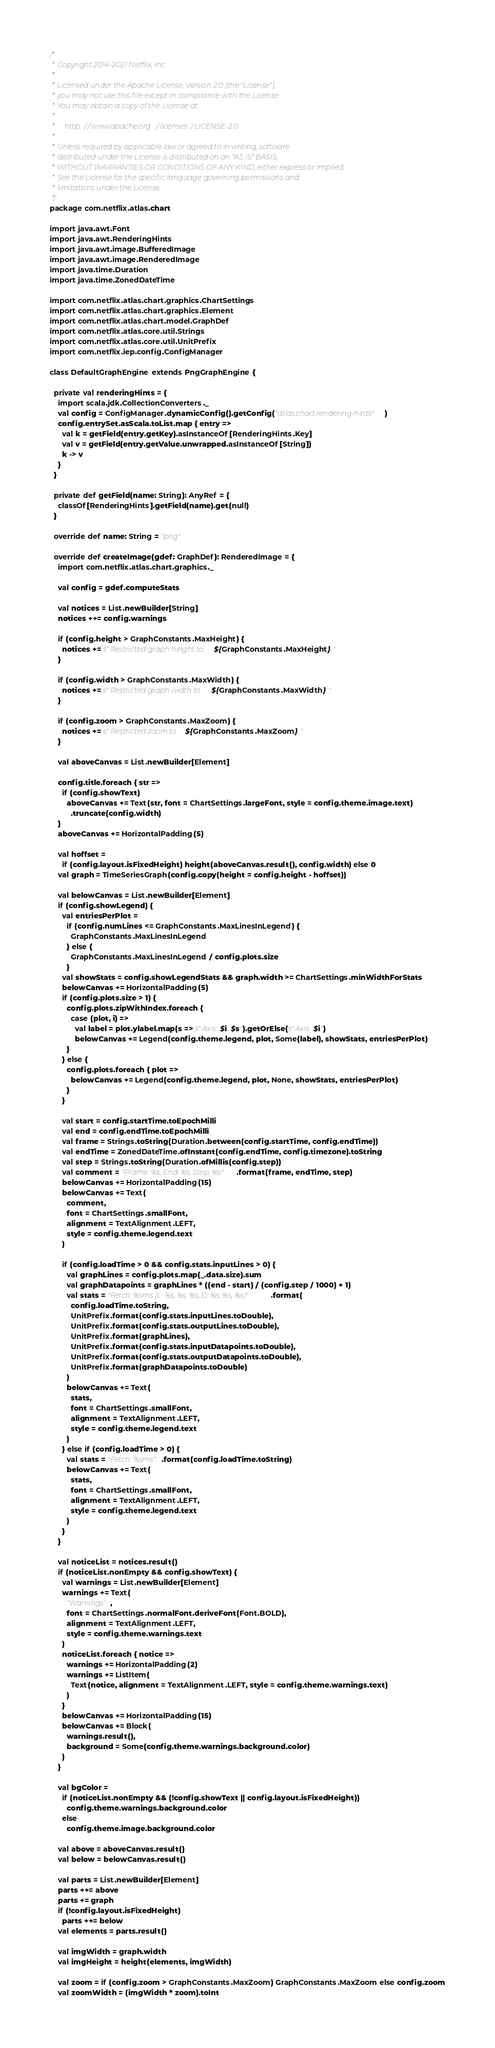Convert code to text. <code><loc_0><loc_0><loc_500><loc_500><_Scala_>/*
 * Copyright 2014-2021 Netflix, Inc.
 *
 * Licensed under the Apache License, Version 2.0 (the "License");
 * you may not use this file except in compliance with the License.
 * You may obtain a copy of the License at
 *
 *     http://www.apache.org/licenses/LICENSE-2.0
 *
 * Unless required by applicable law or agreed to in writing, software
 * distributed under the License is distributed on an "AS IS" BASIS,
 * WITHOUT WARRANTIES OR CONDITIONS OF ANY KIND, either express or implied.
 * See the License for the specific language governing permissions and
 * limitations under the License.
 */
package com.netflix.atlas.chart

import java.awt.Font
import java.awt.RenderingHints
import java.awt.image.BufferedImage
import java.awt.image.RenderedImage
import java.time.Duration
import java.time.ZonedDateTime

import com.netflix.atlas.chart.graphics.ChartSettings
import com.netflix.atlas.chart.graphics.Element
import com.netflix.atlas.chart.model.GraphDef
import com.netflix.atlas.core.util.Strings
import com.netflix.atlas.core.util.UnitPrefix
import com.netflix.iep.config.ConfigManager

class DefaultGraphEngine extends PngGraphEngine {

  private val renderingHints = {
    import scala.jdk.CollectionConverters._
    val config = ConfigManager.dynamicConfig().getConfig("atlas.chart.rendering-hints")
    config.entrySet.asScala.toList.map { entry =>
      val k = getField(entry.getKey).asInstanceOf[RenderingHints.Key]
      val v = getField(entry.getValue.unwrapped.asInstanceOf[String])
      k -> v
    }
  }

  private def getField(name: String): AnyRef = {
    classOf[RenderingHints].getField(name).get(null)
  }

  override def name: String = "png"

  override def createImage(gdef: GraphDef): RenderedImage = {
    import com.netflix.atlas.chart.graphics._

    val config = gdef.computeStats

    val notices = List.newBuilder[String]
    notices ++= config.warnings

    if (config.height > GraphConstants.MaxHeight) {
      notices += s"Restricted graph height to ${GraphConstants.MaxHeight}."
    }

    if (config.width > GraphConstants.MaxWidth) {
      notices += s"Restricted graph width to ${GraphConstants.MaxWidth}."
    }

    if (config.zoom > GraphConstants.MaxZoom) {
      notices += s"Restricted zoom to ${GraphConstants.MaxZoom}."
    }

    val aboveCanvas = List.newBuilder[Element]

    config.title.foreach { str =>
      if (config.showText)
        aboveCanvas += Text(str, font = ChartSettings.largeFont, style = config.theme.image.text)
          .truncate(config.width)
    }
    aboveCanvas += HorizontalPadding(5)

    val hoffset =
      if (config.layout.isFixedHeight) height(aboveCanvas.result(), config.width) else 0
    val graph = TimeSeriesGraph(config.copy(height = config.height - hoffset))

    val belowCanvas = List.newBuilder[Element]
    if (config.showLegend) {
      val entriesPerPlot =
        if (config.numLines <= GraphConstants.MaxLinesInLegend) {
          GraphConstants.MaxLinesInLegend
        } else {
          GraphConstants.MaxLinesInLegend / config.plots.size
        }
      val showStats = config.showLegendStats && graph.width >= ChartSettings.minWidthForStats
      belowCanvas += HorizontalPadding(5)
      if (config.plots.size > 1) {
        config.plots.zipWithIndex.foreach {
          case (plot, i) =>
            val label = plot.ylabel.map(s => s"Axis $i: $s").getOrElse(s"Axis $i")
            belowCanvas += Legend(config.theme.legend, plot, Some(label), showStats, entriesPerPlot)
        }
      } else {
        config.plots.foreach { plot =>
          belowCanvas += Legend(config.theme.legend, plot, None, showStats, entriesPerPlot)
        }
      }

      val start = config.startTime.toEpochMilli
      val end = config.endTime.toEpochMilli
      val frame = Strings.toString(Duration.between(config.startTime, config.endTime))
      val endTime = ZonedDateTime.ofInstant(config.endTime, config.timezone).toString
      val step = Strings.toString(Duration.ofMillis(config.step))
      val comment = "Frame: %s, End: %s, Step: %s".format(frame, endTime, step)
      belowCanvas += HorizontalPadding(15)
      belowCanvas += Text(
        comment,
        font = ChartSettings.smallFont,
        alignment = TextAlignment.LEFT,
        style = config.theme.legend.text
      )

      if (config.loadTime > 0 && config.stats.inputLines > 0) {
        val graphLines = config.plots.map(_.data.size).sum
        val graphDatapoints = graphLines * ((end - start) / (config.step / 1000) + 1)
        val stats = "Fetch: %sms (L: %s, %s, %s; D: %s, %s, %s)".format(
          config.loadTime.toString,
          UnitPrefix.format(config.stats.inputLines.toDouble),
          UnitPrefix.format(config.stats.outputLines.toDouble),
          UnitPrefix.format(graphLines),
          UnitPrefix.format(config.stats.inputDatapoints.toDouble),
          UnitPrefix.format(config.stats.outputDatapoints.toDouble),
          UnitPrefix.format(graphDatapoints.toDouble)
        )
        belowCanvas += Text(
          stats,
          font = ChartSettings.smallFont,
          alignment = TextAlignment.LEFT,
          style = config.theme.legend.text
        )
      } else if (config.loadTime > 0) {
        val stats = "Fetch: %sms".format(config.loadTime.toString)
        belowCanvas += Text(
          stats,
          font = ChartSettings.smallFont,
          alignment = TextAlignment.LEFT,
          style = config.theme.legend.text
        )
      }
    }

    val noticeList = notices.result()
    if (noticeList.nonEmpty && config.showText) {
      val warnings = List.newBuilder[Element]
      warnings += Text(
        "Warnings",
        font = ChartSettings.normalFont.deriveFont(Font.BOLD),
        alignment = TextAlignment.LEFT,
        style = config.theme.warnings.text
      )
      noticeList.foreach { notice =>
        warnings += HorizontalPadding(2)
        warnings += ListItem(
          Text(notice, alignment = TextAlignment.LEFT, style = config.theme.warnings.text)
        )
      }
      belowCanvas += HorizontalPadding(15)
      belowCanvas += Block(
        warnings.result(),
        background = Some(config.theme.warnings.background.color)
      )
    }

    val bgColor =
      if (noticeList.nonEmpty && (!config.showText || config.layout.isFixedHeight))
        config.theme.warnings.background.color
      else
        config.theme.image.background.color

    val above = aboveCanvas.result()
    val below = belowCanvas.result()

    val parts = List.newBuilder[Element]
    parts ++= above
    parts += graph
    if (!config.layout.isFixedHeight)
      parts ++= below
    val elements = parts.result()

    val imgWidth = graph.width
    val imgHeight = height(elements, imgWidth)

    val zoom = if (config.zoom > GraphConstants.MaxZoom) GraphConstants.MaxZoom else config.zoom
    val zoomWidth = (imgWidth * zoom).toInt</code> 